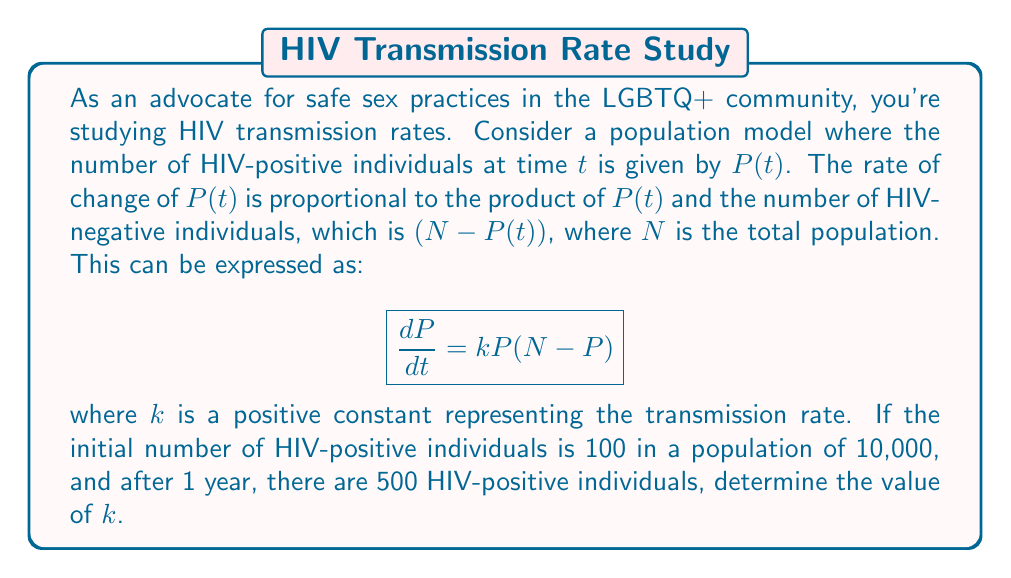Help me with this question. Let's solve this step-by-step:

1) We have the differential equation:
   $$ \frac{dP}{dt} = kP(N - P) $$

2) This is a separable equation. We can rewrite it as:
   $$ \frac{dP}{P(N - P)} = k dt $$

3) Integrating both sides:
   $$ \int \frac{dP}{P(N - P)} = \int k dt $$

4) The left side integrates to:
   $$ \frac{1}{N} \ln\left|\frac{P}{N-P}\right| = kt + C $$

5) Using the initial condition: At t = 0, P = 100, N = 10,000
   $$ \frac{1}{10000} \ln\left|\frac{100}{9900}\right| = C $$

6) After 1 year (t = 1), P = 500:
   $$ \frac{1}{10000} \ln\left|\frac{500}{9500}\right| = k(1) + C $$

7) Subtracting the equations in steps 5 and 6:
   $$ \frac{1}{10000} \ln\left|\frac{500}{9500}\right| - \frac{1}{10000} \ln\left|\frac{100}{9900}\right| = k $$

8) Simplifying:
   $$ k = \frac{1}{10000} \ln\left|\frac{500 \cdot 9900}{100 \cdot 9500}\right| $$

9) Calculate the value:
   $$ k \approx 1.609 \times 10^{-5} $$
Answer: $k \approx 1.609 \times 10^{-5}$ 